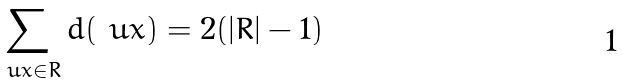Convert formula to latex. <formula><loc_0><loc_0><loc_500><loc_500>\sum _ { \ u x \in R } d ( \ u x ) = 2 ( | R | - 1 )</formula> 